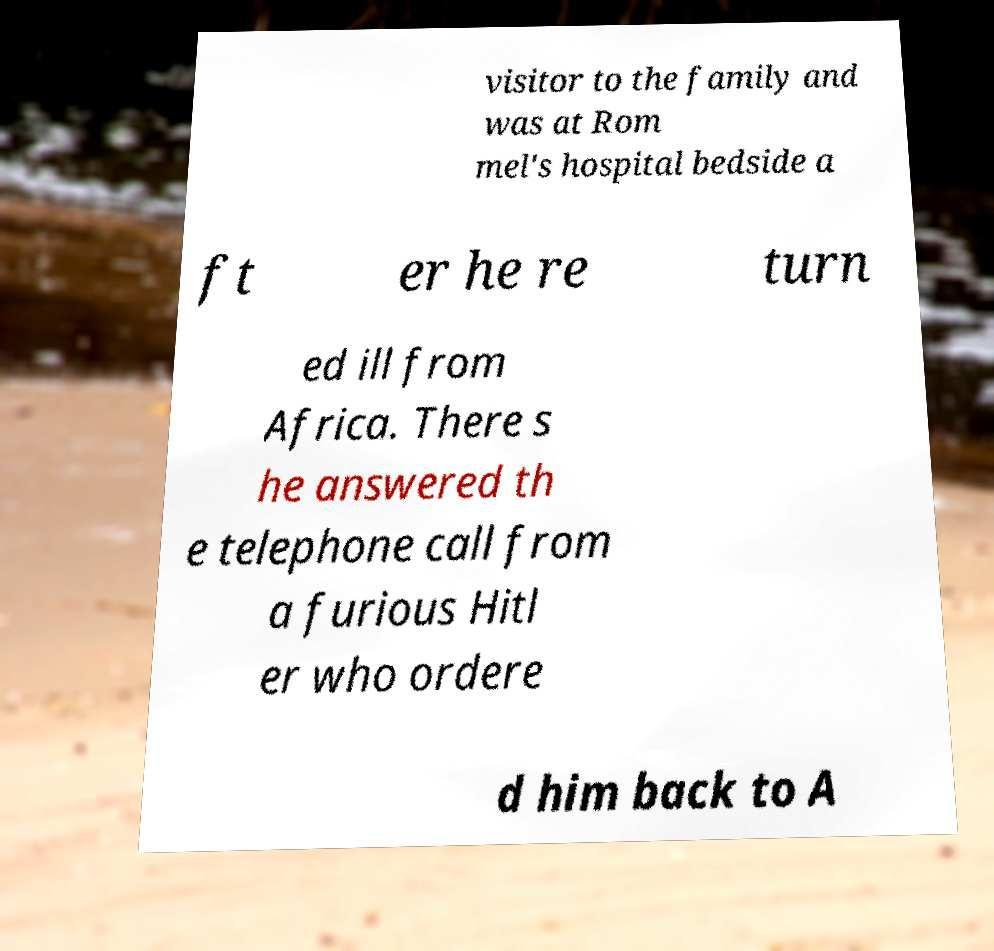Please identify and transcribe the text found in this image. visitor to the family and was at Rom mel's hospital bedside a ft er he re turn ed ill from Africa. There s he answered th e telephone call from a furious Hitl er who ordere d him back to A 